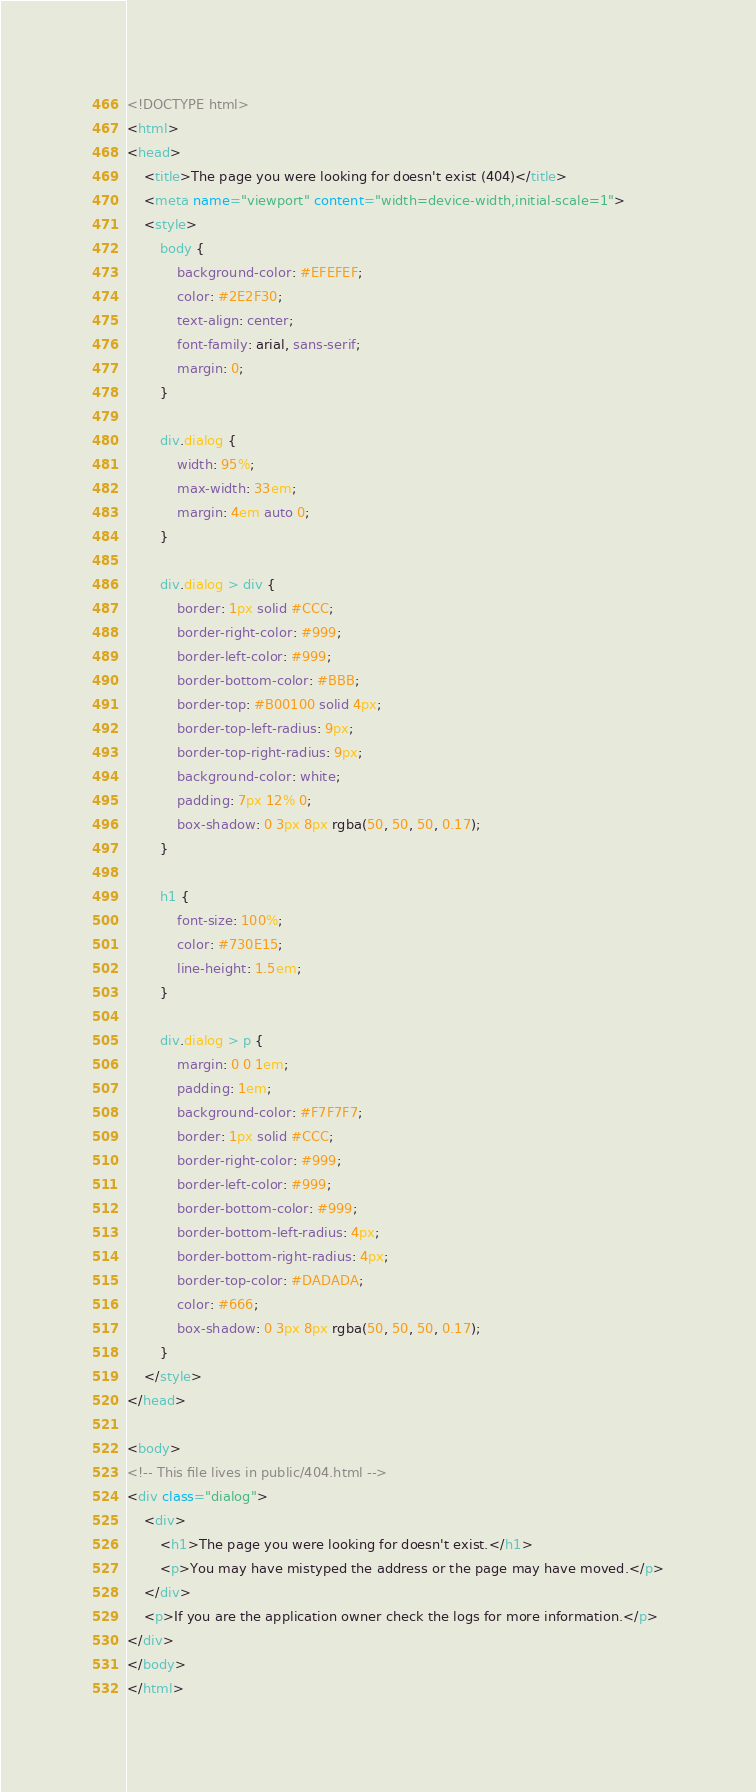<code> <loc_0><loc_0><loc_500><loc_500><_HTML_><!DOCTYPE html>
<html>
<head>
    <title>The page you were looking for doesn't exist (404)</title>
    <meta name="viewport" content="width=device-width,initial-scale=1">
    <style>
        body {
            background-color: #EFEFEF;
            color: #2E2F30;
            text-align: center;
            font-family: arial, sans-serif;
            margin: 0;
        }

        div.dialog {
            width: 95%;
            max-width: 33em;
            margin: 4em auto 0;
        }

        div.dialog > div {
            border: 1px solid #CCC;
            border-right-color: #999;
            border-left-color: #999;
            border-bottom-color: #BBB;
            border-top: #B00100 solid 4px;
            border-top-left-radius: 9px;
            border-top-right-radius: 9px;
            background-color: white;
            padding: 7px 12% 0;
            box-shadow: 0 3px 8px rgba(50, 50, 50, 0.17);
        }

        h1 {
            font-size: 100%;
            color: #730E15;
            line-height: 1.5em;
        }

        div.dialog > p {
            margin: 0 0 1em;
            padding: 1em;
            background-color: #F7F7F7;
            border: 1px solid #CCC;
            border-right-color: #999;
            border-left-color: #999;
            border-bottom-color: #999;
            border-bottom-left-radius: 4px;
            border-bottom-right-radius: 4px;
            border-top-color: #DADADA;
            color: #666;
            box-shadow: 0 3px 8px rgba(50, 50, 50, 0.17);
        }
    </style>
</head>

<body>
<!-- This file lives in public/404.html -->
<div class="dialog">
    <div>
        <h1>The page you were looking for doesn't exist.</h1>
        <p>You may have mistyped the address or the page may have moved.</p>
    </div>
    <p>If you are the application owner check the logs for more information.</p>
</div>
</body>
</html>
</code> 